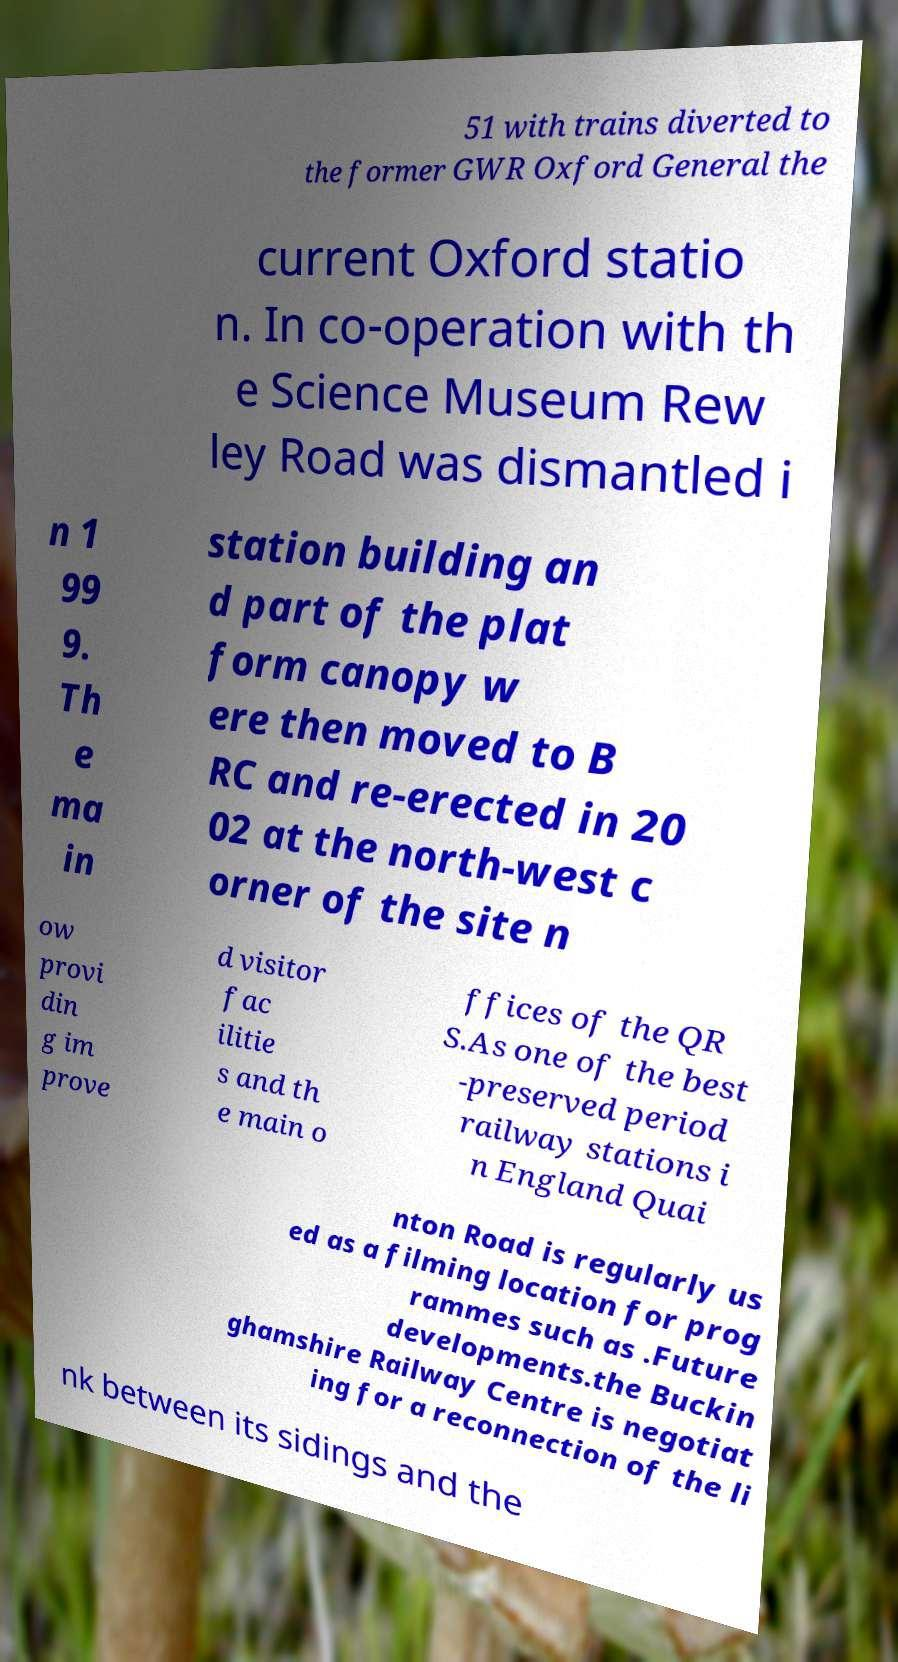Please identify and transcribe the text found in this image. 51 with trains diverted to the former GWR Oxford General the current Oxford statio n. In co-operation with th e Science Museum Rew ley Road was dismantled i n 1 99 9. Th e ma in station building an d part of the plat form canopy w ere then moved to B RC and re-erected in 20 02 at the north-west c orner of the site n ow provi din g im prove d visitor fac ilitie s and th e main o ffices of the QR S.As one of the best -preserved period railway stations i n England Quai nton Road is regularly us ed as a filming location for prog rammes such as .Future developments.the Buckin ghamshire Railway Centre is negotiat ing for a reconnection of the li nk between its sidings and the 